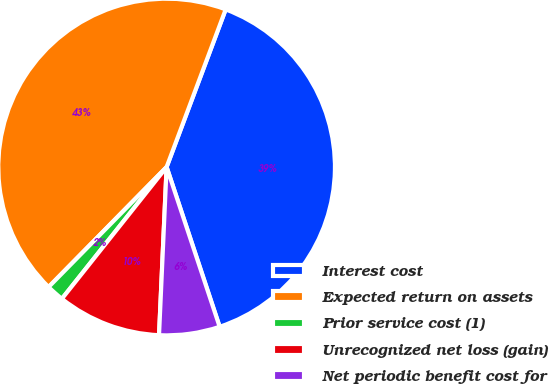Convert chart to OTSL. <chart><loc_0><loc_0><loc_500><loc_500><pie_chart><fcel>Interest cost<fcel>Expected return on assets<fcel>Prior service cost (1)<fcel>Unrecognized net loss (gain)<fcel>Net periodic benefit cost for<nl><fcel>39.19%<fcel>43.34%<fcel>1.68%<fcel>9.97%<fcel>5.82%<nl></chart> 